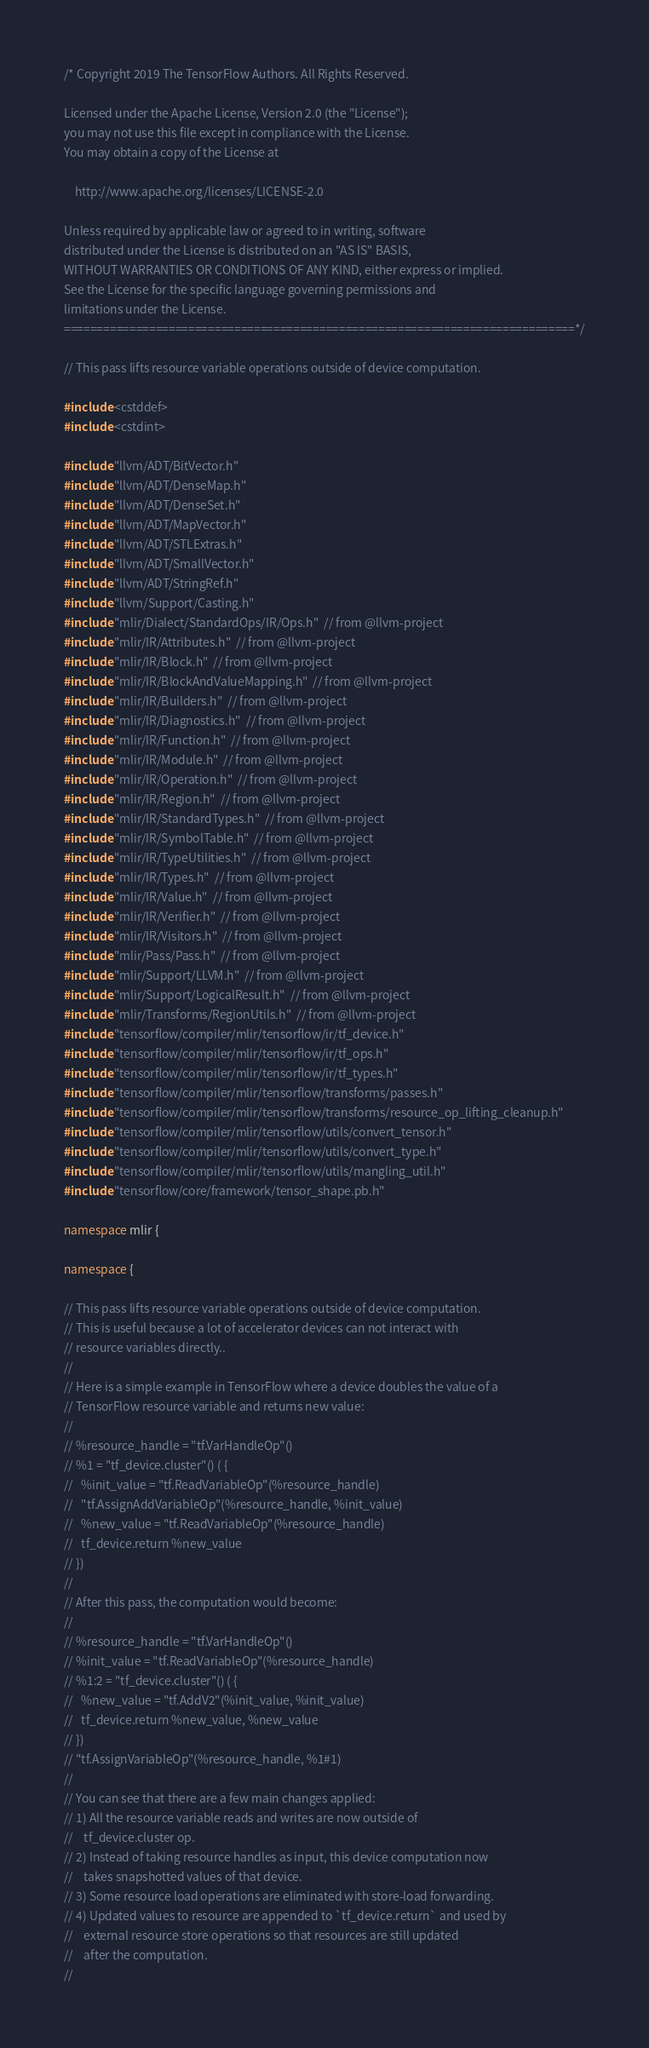Convert code to text. <code><loc_0><loc_0><loc_500><loc_500><_C++_>/* Copyright 2019 The TensorFlow Authors. All Rights Reserved.

Licensed under the Apache License, Version 2.0 (the "License");
you may not use this file except in compliance with the License.
You may obtain a copy of the License at

    http://www.apache.org/licenses/LICENSE-2.0

Unless required by applicable law or agreed to in writing, software
distributed under the License is distributed on an "AS IS" BASIS,
WITHOUT WARRANTIES OR CONDITIONS OF ANY KIND, either express or implied.
See the License for the specific language governing permissions and
limitations under the License.
==============================================================================*/

// This pass lifts resource variable operations outside of device computation.

#include <cstddef>
#include <cstdint>

#include "llvm/ADT/BitVector.h"
#include "llvm/ADT/DenseMap.h"
#include "llvm/ADT/DenseSet.h"
#include "llvm/ADT/MapVector.h"
#include "llvm/ADT/STLExtras.h"
#include "llvm/ADT/SmallVector.h"
#include "llvm/ADT/StringRef.h"
#include "llvm/Support/Casting.h"
#include "mlir/Dialect/StandardOps/IR/Ops.h"  // from @llvm-project
#include "mlir/IR/Attributes.h"  // from @llvm-project
#include "mlir/IR/Block.h"  // from @llvm-project
#include "mlir/IR/BlockAndValueMapping.h"  // from @llvm-project
#include "mlir/IR/Builders.h"  // from @llvm-project
#include "mlir/IR/Diagnostics.h"  // from @llvm-project
#include "mlir/IR/Function.h"  // from @llvm-project
#include "mlir/IR/Module.h"  // from @llvm-project
#include "mlir/IR/Operation.h"  // from @llvm-project
#include "mlir/IR/Region.h"  // from @llvm-project
#include "mlir/IR/StandardTypes.h"  // from @llvm-project
#include "mlir/IR/SymbolTable.h"  // from @llvm-project
#include "mlir/IR/TypeUtilities.h"  // from @llvm-project
#include "mlir/IR/Types.h"  // from @llvm-project
#include "mlir/IR/Value.h"  // from @llvm-project
#include "mlir/IR/Verifier.h"  // from @llvm-project
#include "mlir/IR/Visitors.h"  // from @llvm-project
#include "mlir/Pass/Pass.h"  // from @llvm-project
#include "mlir/Support/LLVM.h"  // from @llvm-project
#include "mlir/Support/LogicalResult.h"  // from @llvm-project
#include "mlir/Transforms/RegionUtils.h"  // from @llvm-project
#include "tensorflow/compiler/mlir/tensorflow/ir/tf_device.h"
#include "tensorflow/compiler/mlir/tensorflow/ir/tf_ops.h"
#include "tensorflow/compiler/mlir/tensorflow/ir/tf_types.h"
#include "tensorflow/compiler/mlir/tensorflow/transforms/passes.h"
#include "tensorflow/compiler/mlir/tensorflow/transforms/resource_op_lifting_cleanup.h"
#include "tensorflow/compiler/mlir/tensorflow/utils/convert_tensor.h"
#include "tensorflow/compiler/mlir/tensorflow/utils/convert_type.h"
#include "tensorflow/compiler/mlir/tensorflow/utils/mangling_util.h"
#include "tensorflow/core/framework/tensor_shape.pb.h"

namespace mlir {

namespace {

// This pass lifts resource variable operations outside of device computation.
// This is useful because a lot of accelerator devices can not interact with
// resource variables directly..
//
// Here is a simple example in TensorFlow where a device doubles the value of a
// TensorFlow resource variable and returns new value:
//
// %resource_handle = "tf.VarHandleOp"()
// %1 = "tf_device.cluster"() ( {
//   %init_value = "tf.ReadVariableOp"(%resource_handle)
//   "tf.AssignAddVariableOp"(%resource_handle, %init_value)
//   %new_value = "tf.ReadVariableOp"(%resource_handle)
//   tf_device.return %new_value
// })
//
// After this pass, the computation would become:
//
// %resource_handle = "tf.VarHandleOp"()
// %init_value = "tf.ReadVariableOp"(%resource_handle)
// %1:2 = "tf_device.cluster"() ( {
//   %new_value = "tf.AddV2"(%init_value, %init_value)
//   tf_device.return %new_value, %new_value
// })
// "tf.AssignVariableOp"(%resource_handle, %1#1)
//
// You can see that there are a few main changes applied:
// 1) All the resource variable reads and writes are now outside of
//    tf_device.cluster op.
// 2) Instead of taking resource handles as input, this device computation now
//    takes snapshotted values of that device.
// 3) Some resource load operations are eliminated with store-load forwarding.
// 4) Updated values to resource are appended to `tf_device.return` and used by
//    external resource store operations so that resources are still updated
//    after the computation.
//</code> 